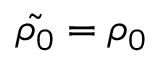<formula> <loc_0><loc_0><loc_500><loc_500>\tilde { \rho _ { 0 } } = \rho _ { 0 }</formula> 